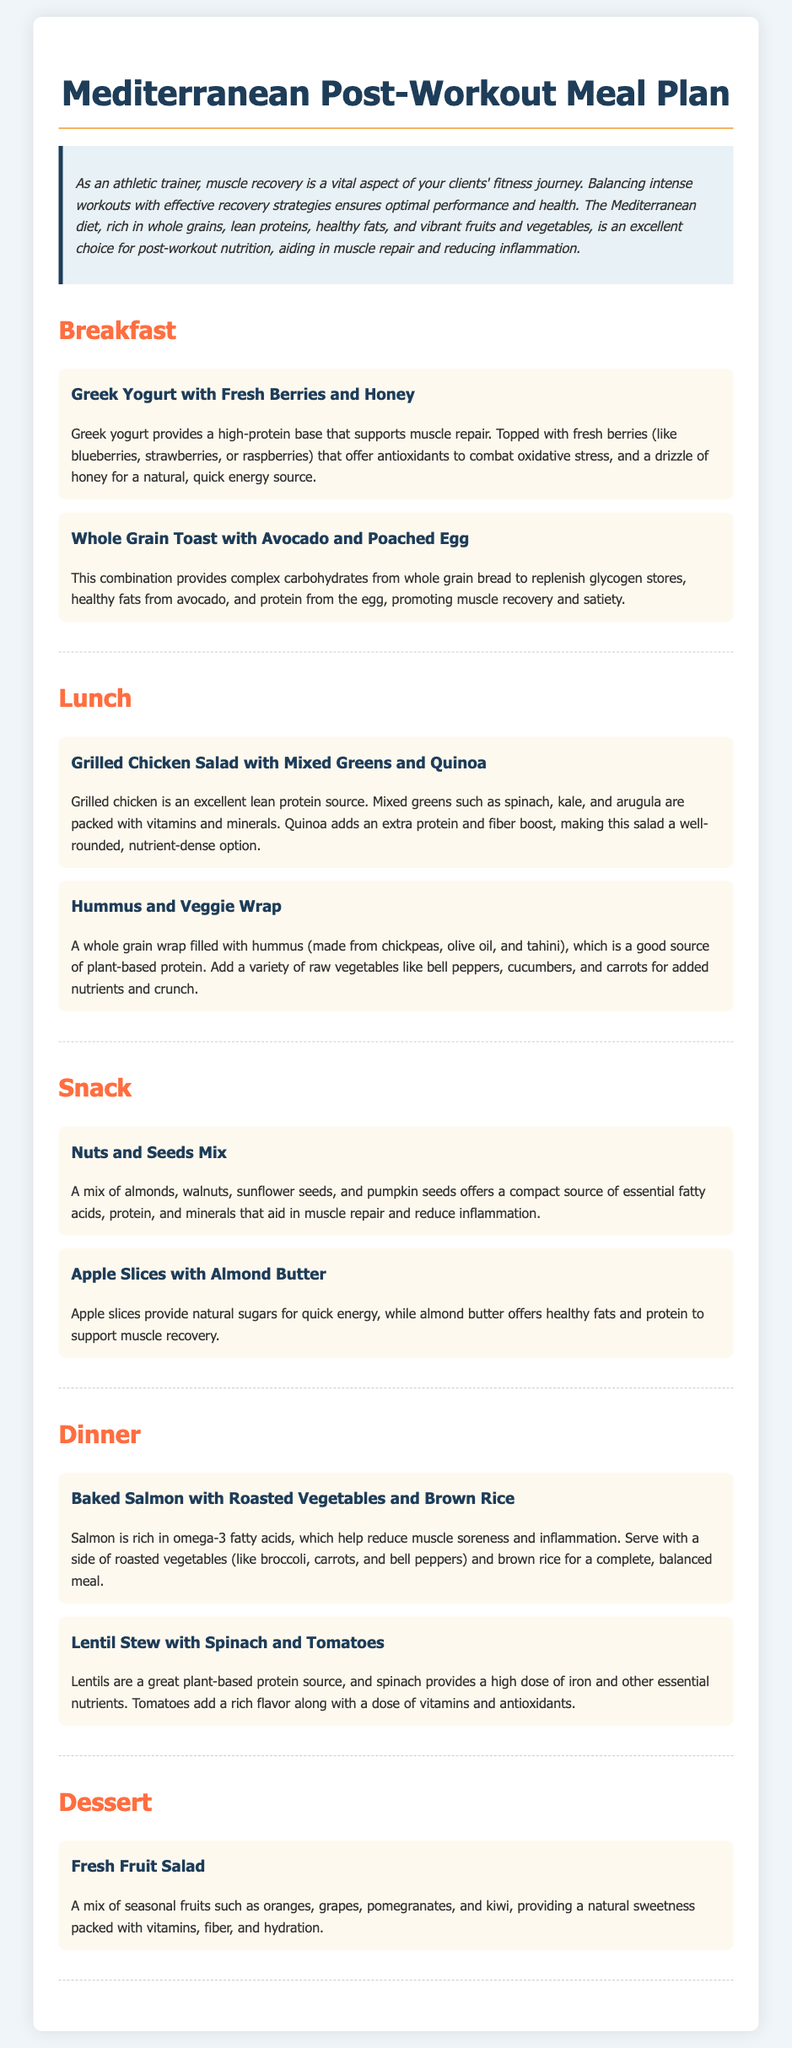What is the primary diet mentioned in the meal plan? The document centers around meal options based on the Mediterranean diet principles, which focus on nutritious foods for muscle recovery.
Answer: Mediterranean diet Which meal features Greek yogurt? The document mentions Greek yogurt as part of the breakfast meal, highlighting its protein content for muscle repair.
Answer: Breakfast How many different snack options are presented? The document lists two snack options: Nuts and Seeds Mix, and Apple Slices with Almond Butter.
Answer: 2 What main protein source is included in the dinner section? Baked Salmon is highlighted as a key protein source in the dinner section, rich in omega-3 fatty acids that help reduce muscle soreness.
Answer: Salmon Which carbohydrate source is suggested for dinner? The dinner meal plan includes brown rice as a carbohydrate source to complement the salmon and vegetables.
Answer: Brown rice What type of vegetable is used in the lentil stew recipe? The recipe for lentil stew prominently features spinach as one of the vegetables included for its nutrients.
Answer: Spinach What is provided in the dessert section? The dessert section contains a Fresh Fruit Salad, which includes a variety of seasonal fruits for sweetness and vitamins.
Answer: Fresh Fruit Salad What is the suggested post-workout breakfast choice? The breakfast options suggested in the meal plan include Greek Yogurt with Fresh Berries and Honey or Whole Grain Toast with Avocado and Poached Egg.
Answer: Greek Yogurt with Fresh Berries and Honey What is the calorie range for the entire meal plan discussed? The document does not specify calorie information, as it focuses more on meal components rather than a calorie count.
Answer: Not specified 